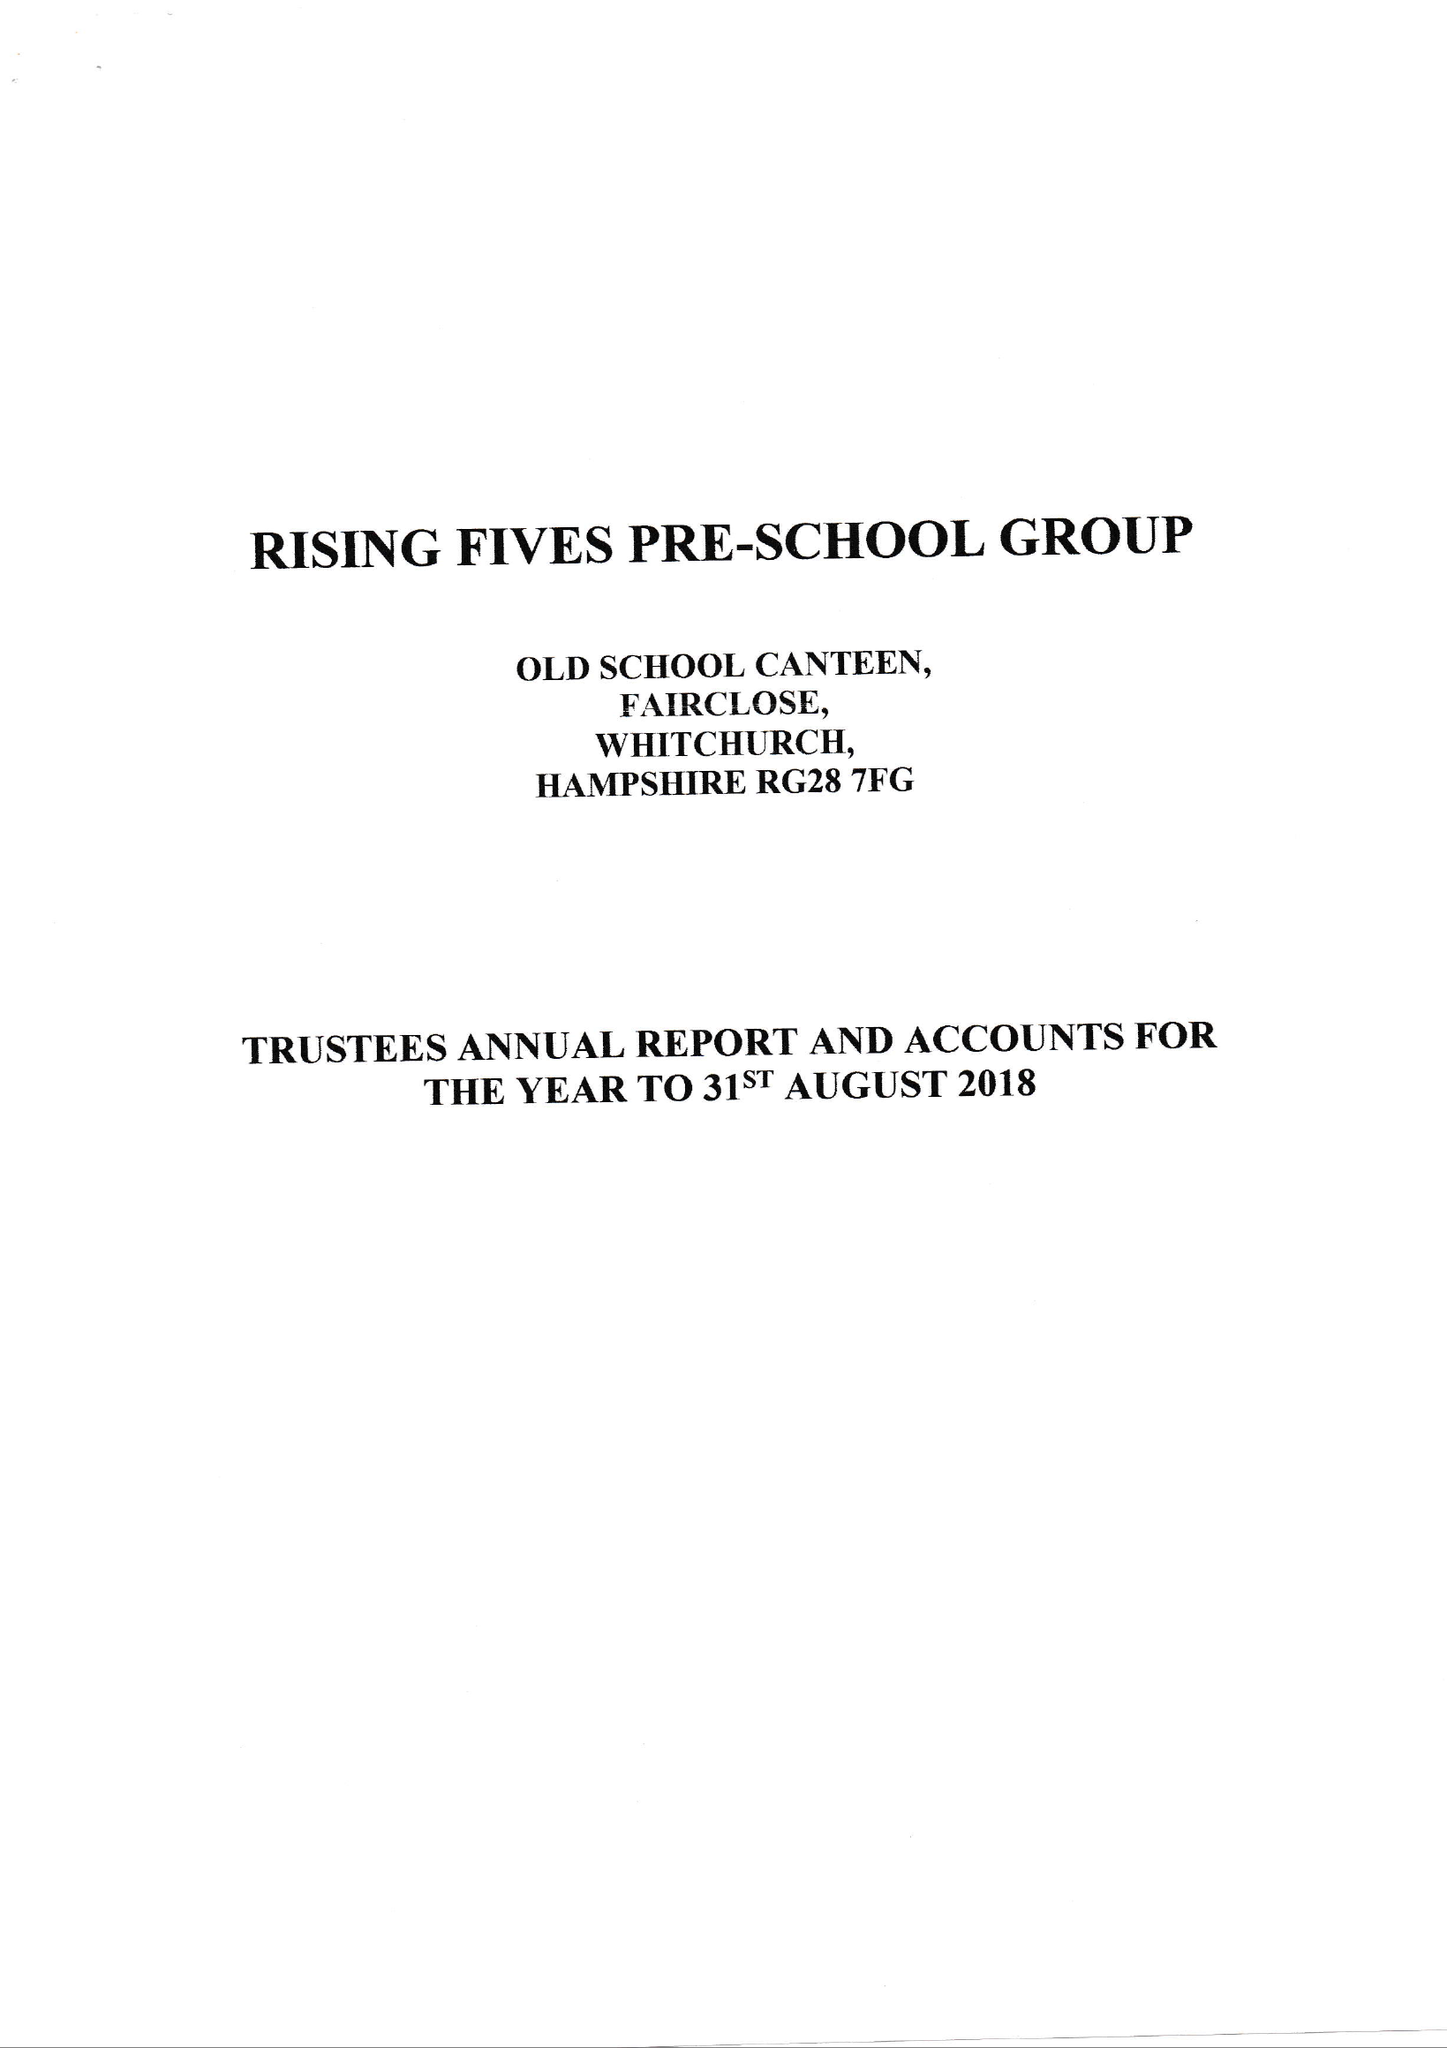What is the value for the address__postcode?
Answer the question using a single word or phrase. RG28 7AN 